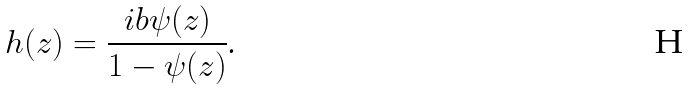Convert formula to latex. <formula><loc_0><loc_0><loc_500><loc_500>h ( z ) = \frac { i b \psi ( z ) } { 1 - \psi ( z ) } \text {.}</formula> 